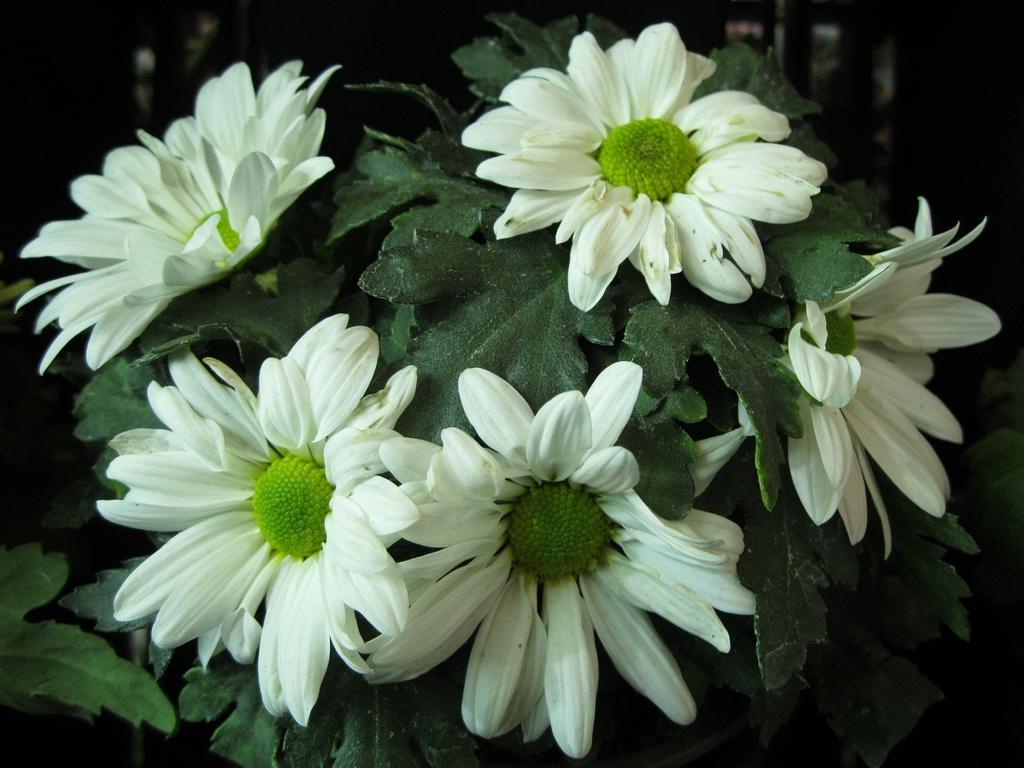Describe this image in one or two sentences. In the image there is a white sunflower plant. 